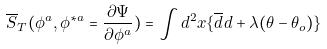<formula> <loc_0><loc_0><loc_500><loc_500>\overline { S } _ { T } ( \phi ^ { a } , \phi ^ { \ast a } = \frac { \partial \Psi } { \partial \phi ^ { a } } ) = \int d ^ { 2 } x \{ \overline { d } d + \lambda ( \theta - \theta _ { o } ) \}</formula> 